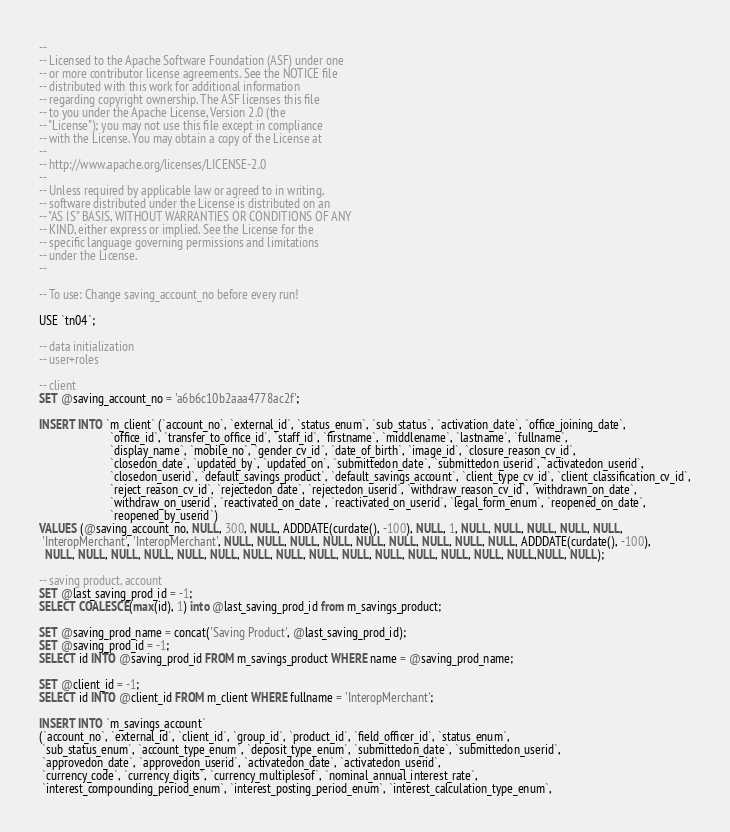Convert code to text. <code><loc_0><loc_0><loc_500><loc_500><_SQL_>--
-- Licensed to the Apache Software Foundation (ASF) under one
-- or more contributor license agreements. See the NOTICE file
-- distributed with this work for additional information
-- regarding copyright ownership. The ASF licenses this file
-- to you under the Apache License, Version 2.0 (the
-- "License"); you may not use this file except in compliance
-- with the License. You may obtain a copy of the License at
--
-- http://www.apache.org/licenses/LICENSE-2.0
--
-- Unless required by applicable law or agreed to in writing,
-- software distributed under the License is distributed on an
-- "AS IS" BASIS, WITHOUT WARRANTIES OR CONDITIONS OF ANY
-- KIND, either express or implied. See the License for the
-- specific language governing permissions and limitations
-- under the License.
--

-- To use: Change saving_account_no before every run!

USE `tn04`;

-- data initialization
-- user+roles

-- client
SET @saving_account_no = 'a6b6c10b2aaa4778ac2f';

INSERT INTO `m_client` (`account_no`, `external_id`, `status_enum`, `sub_status`, `activation_date`, `office_joining_date`,
                        `office_id`, `transfer_to_office_id`, `staff_id`, `firstname`, `middlename`, `lastname`, `fullname`,
                        `display_name`, `mobile_no`, `gender_cv_id`, `date_of_birth`, `image_id`, `closure_reason_cv_id`,
                        `closedon_date`, `updated_by`, `updated_on`, `submittedon_date`, `submittedon_userid`, `activatedon_userid`,
                        `closedon_userid`, `default_savings_product`, `default_savings_account`, `client_type_cv_id`, `client_classification_cv_id`,
                        `reject_reason_cv_id`, `rejectedon_date`, `rejectedon_userid`, `withdraw_reason_cv_id`, `withdrawn_on_date`,
                        `withdraw_on_userid`, `reactivated_on_date`, `reactivated_on_userid`, `legal_form_enum`, `reopened_on_date`,
                        `reopened_by_userid`)
VALUES (@saving_account_no, NULL, 300, NULL, ADDDATE(curdate(), -100), NULL, 1, NULL, NULL, NULL, NULL, NULL,
 'InteropMerchant', 'InteropMerchant', NULL, NULL, NULL, NULL, NULL, NULL, NULL, NULL, NULL, ADDDATE(curdate(), -100),
  NULL, NULL, NULL, NULL, NULL, NULL, NULL, NULL, NULL, NULL, NULL, NULL, NULL, NULL, NULL,NULL, NULL);

-- saving product, account
SET @last_saving_prod_id = -1;
SELECT COALESCE(max(id), 1) into @last_saving_prod_id from m_savings_product;

SET @saving_prod_name = concat('Saving Product', @last_saving_prod_id);
SET @saving_prod_id = -1;
SELECT id INTO @saving_prod_id FROM m_savings_product WHERE name = @saving_prod_name;

SET @client_id = -1;
SELECT id INTO @client_id FROM m_client WHERE fullname = 'InteropMerchant';

INSERT INTO `m_savings_account`
(`account_no`, `external_id`, `client_id`, `group_id`, `product_id`, `field_officer_id`, `status_enum`,
 `sub_status_enum`, `account_type_enum`, `deposit_type_enum`, `submittedon_date`, `submittedon_userid`,
 `approvedon_date`, `approvedon_userid`, `activatedon_date`, `activatedon_userid`,
 `currency_code`, `currency_digits`, `currency_multiplesof`, `nominal_annual_interest_rate`,
 `interest_compounding_period_enum`, `interest_posting_period_enum`, `interest_calculation_type_enum`,</code> 